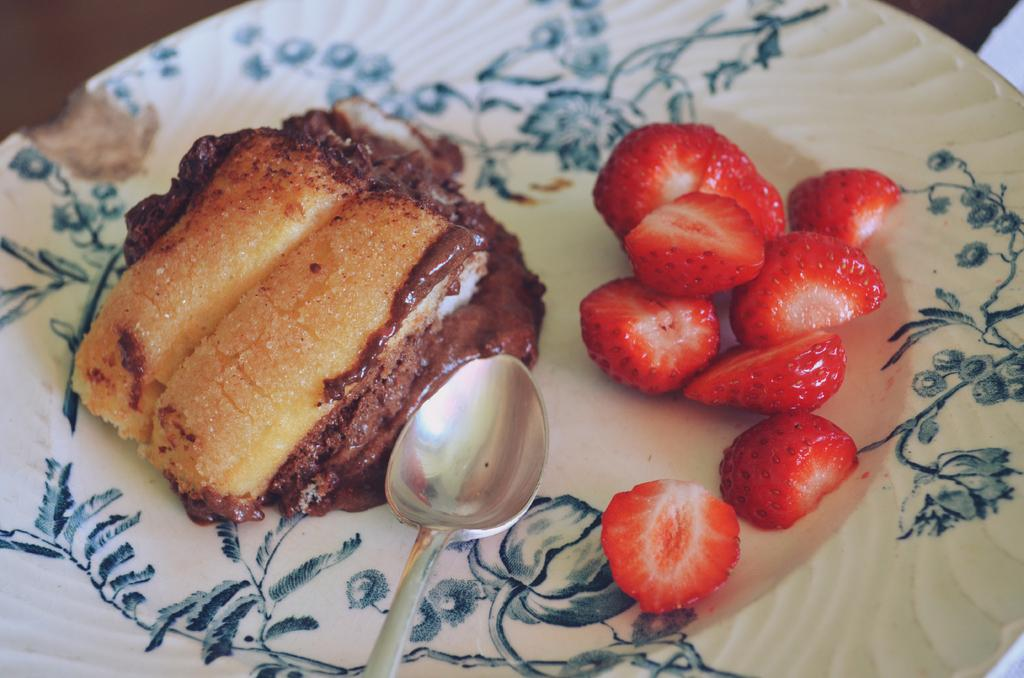What is on the plate in the image? There is a food item on the plate in the image. Can you describe the food item on the plate? The food item on the plate is not specified, but it is visible in the image. What type of fruit can be seen in the image? There are slices of strawberries in the image. What utensil is present in the image? There is a spoon in the image. How many socks are visible in the image? There are no socks visible in the image. 